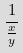Convert formula to latex. <formula><loc_0><loc_0><loc_500><loc_500>\frac { 1 } { \frac { x } { y } }</formula> 